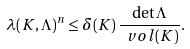Convert formula to latex. <formula><loc_0><loc_0><loc_500><loc_500>\lambda ( K , \Lambda ) ^ { n } \leq \delta ( K ) \, \frac { \det \Lambda } { \ v o l ( K ) } .</formula> 